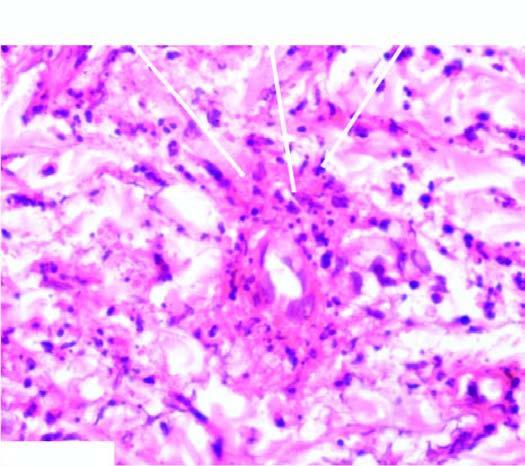does the vessel wall show fibrinoid necrosis surrounded by viable as well as fragmented neutrophils?
Answer the question using a single word or phrase. Yes 